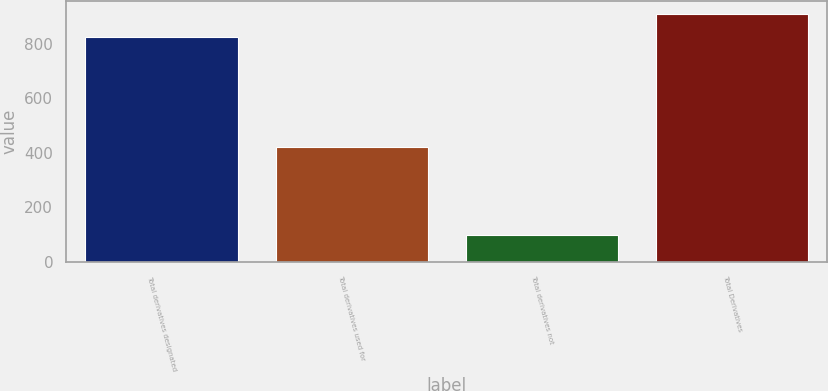Convert chart to OTSL. <chart><loc_0><loc_0><loc_500><loc_500><bar_chart><fcel>Total derivatives designated<fcel>Total derivatives used for<fcel>Total derivatives not<fcel>Total Derivatives<nl><fcel>825<fcel>422<fcel>96.7<fcel>909.7<nl></chart> 